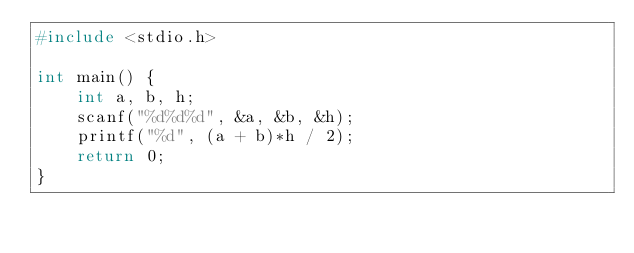<code> <loc_0><loc_0><loc_500><loc_500><_C_>#include <stdio.h>

int main() {
	int a, b, h;
	scanf("%d%d%d", &a, &b, &h);
	printf("%d", (a + b)*h / 2);
	return 0;
}</code> 